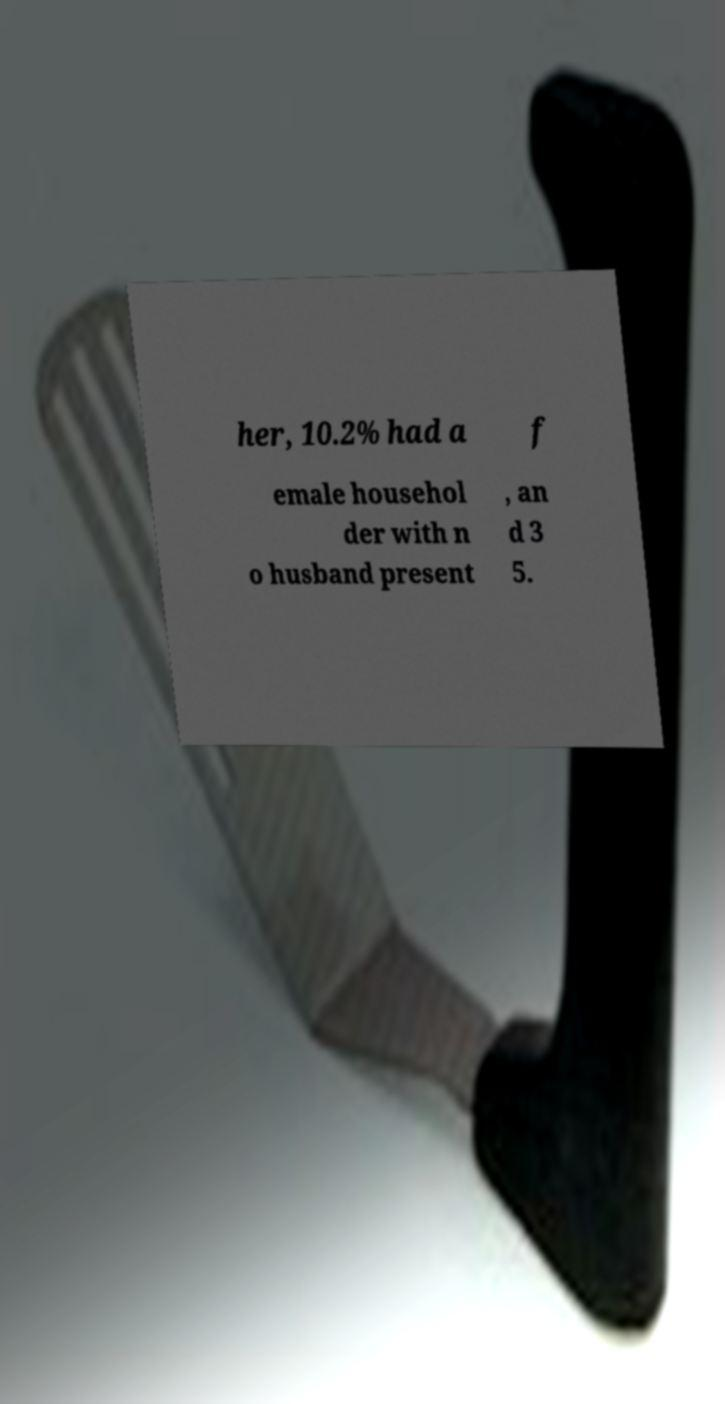Can you accurately transcribe the text from the provided image for me? her, 10.2% had a f emale househol der with n o husband present , an d 3 5. 